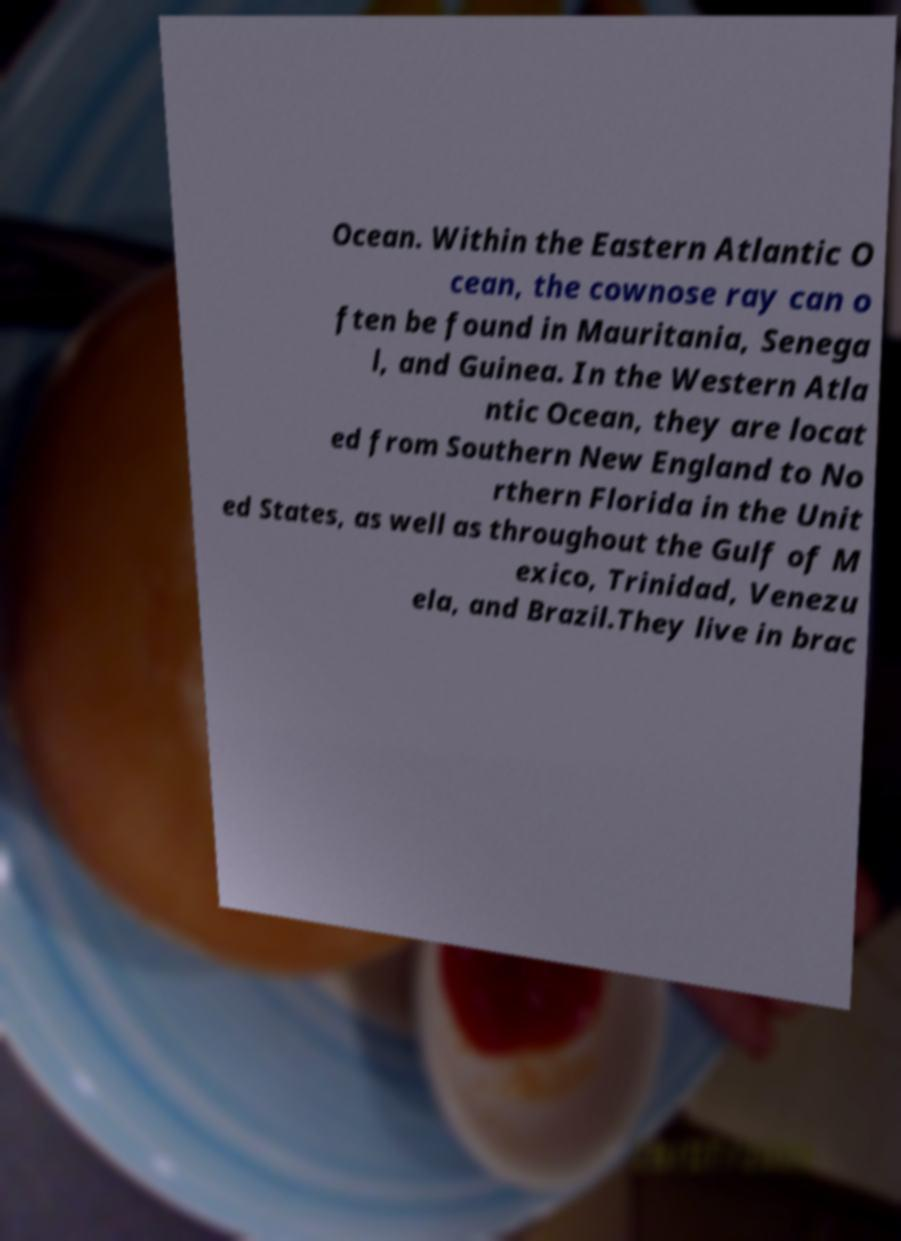Can you read and provide the text displayed in the image?This photo seems to have some interesting text. Can you extract and type it out for me? Ocean. Within the Eastern Atlantic O cean, the cownose ray can o ften be found in Mauritania, Senega l, and Guinea. In the Western Atla ntic Ocean, they are locat ed from Southern New England to No rthern Florida in the Unit ed States, as well as throughout the Gulf of M exico, Trinidad, Venezu ela, and Brazil.They live in brac 